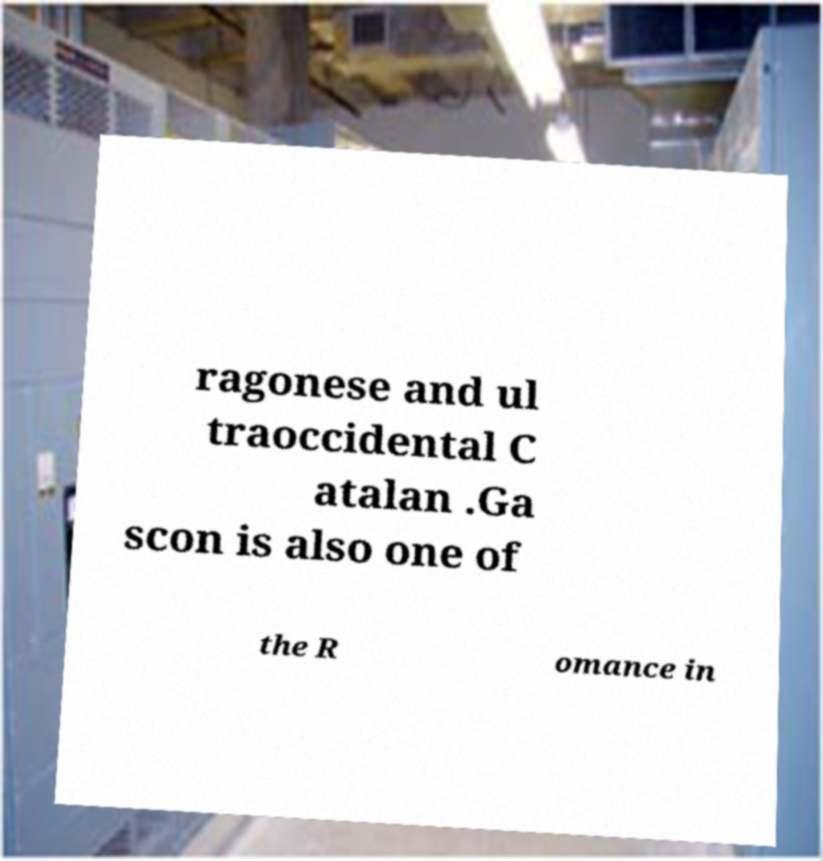Please read and relay the text visible in this image. What does it say? ragonese and ul traoccidental C atalan .Ga scon is also one of the R omance in 